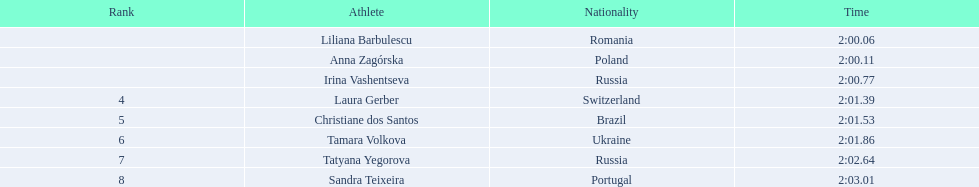Who were the athlete were in the athletics at the 2003 summer universiade - women's 800 metres? , Liliana Barbulescu, Anna Zagórska, Irina Vashentseva, Laura Gerber, Christiane dos Santos, Tamara Volkova, Tatyana Yegorova, Sandra Teixeira. What was anna zagorska finishing time? 2:00.11. 